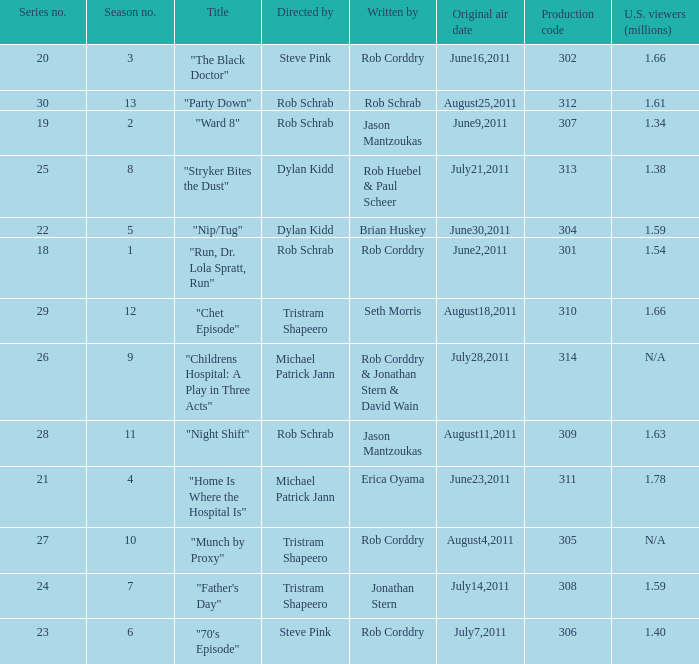The episode entitled "ward 8" was what number in the series? 19.0. 